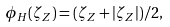Convert formula to latex. <formula><loc_0><loc_0><loc_500><loc_500>\phi _ { H } ( \zeta _ { Z } ) = ( \zeta _ { Z } + | \zeta _ { Z } | ) / 2 ,</formula> 